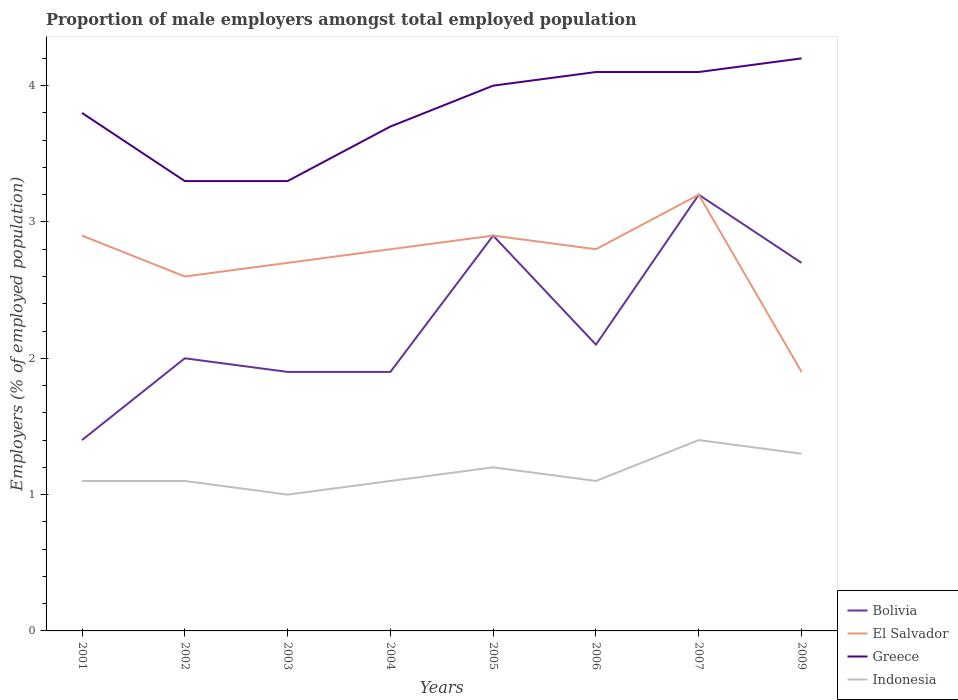How many different coloured lines are there?
Keep it short and to the point. 4. Across all years, what is the maximum proportion of male employers in Indonesia?
Ensure brevity in your answer.  1. In which year was the proportion of male employers in Bolivia maximum?
Give a very brief answer. 2001. What is the total proportion of male employers in Bolivia in the graph?
Give a very brief answer. 0.2. What is the difference between the highest and the second highest proportion of male employers in Bolivia?
Your response must be concise. 1.8. Are the values on the major ticks of Y-axis written in scientific E-notation?
Your response must be concise. No. Does the graph contain any zero values?
Provide a short and direct response. No. Does the graph contain grids?
Provide a short and direct response. No. How are the legend labels stacked?
Offer a terse response. Vertical. What is the title of the graph?
Provide a short and direct response. Proportion of male employers amongst total employed population. Does "Czech Republic" appear as one of the legend labels in the graph?
Your answer should be compact. No. What is the label or title of the X-axis?
Your answer should be very brief. Years. What is the label or title of the Y-axis?
Keep it short and to the point. Employers (% of employed population). What is the Employers (% of employed population) of Bolivia in 2001?
Offer a terse response. 1.4. What is the Employers (% of employed population) in El Salvador in 2001?
Keep it short and to the point. 2.9. What is the Employers (% of employed population) in Greece in 2001?
Your answer should be compact. 3.8. What is the Employers (% of employed population) of Indonesia in 2001?
Your response must be concise. 1.1. What is the Employers (% of employed population) in Bolivia in 2002?
Make the answer very short. 2. What is the Employers (% of employed population) of El Salvador in 2002?
Give a very brief answer. 2.6. What is the Employers (% of employed population) in Greece in 2002?
Keep it short and to the point. 3.3. What is the Employers (% of employed population) in Indonesia in 2002?
Give a very brief answer. 1.1. What is the Employers (% of employed population) in Bolivia in 2003?
Your answer should be compact. 1.9. What is the Employers (% of employed population) of El Salvador in 2003?
Offer a terse response. 2.7. What is the Employers (% of employed population) in Greece in 2003?
Your answer should be compact. 3.3. What is the Employers (% of employed population) in Bolivia in 2004?
Make the answer very short. 1.9. What is the Employers (% of employed population) in El Salvador in 2004?
Give a very brief answer. 2.8. What is the Employers (% of employed population) of Greece in 2004?
Offer a very short reply. 3.7. What is the Employers (% of employed population) in Indonesia in 2004?
Your answer should be very brief. 1.1. What is the Employers (% of employed population) in Bolivia in 2005?
Make the answer very short. 2.9. What is the Employers (% of employed population) of El Salvador in 2005?
Provide a succinct answer. 2.9. What is the Employers (% of employed population) in Greece in 2005?
Your response must be concise. 4. What is the Employers (% of employed population) of Indonesia in 2005?
Your answer should be compact. 1.2. What is the Employers (% of employed population) of Bolivia in 2006?
Offer a very short reply. 2.1. What is the Employers (% of employed population) in El Salvador in 2006?
Keep it short and to the point. 2.8. What is the Employers (% of employed population) in Greece in 2006?
Offer a terse response. 4.1. What is the Employers (% of employed population) of Indonesia in 2006?
Give a very brief answer. 1.1. What is the Employers (% of employed population) in Bolivia in 2007?
Your answer should be compact. 3.2. What is the Employers (% of employed population) of El Salvador in 2007?
Offer a terse response. 3.2. What is the Employers (% of employed population) of Greece in 2007?
Your answer should be very brief. 4.1. What is the Employers (% of employed population) in Indonesia in 2007?
Your answer should be compact. 1.4. What is the Employers (% of employed population) in Bolivia in 2009?
Your answer should be very brief. 2.7. What is the Employers (% of employed population) in El Salvador in 2009?
Your response must be concise. 1.9. What is the Employers (% of employed population) in Greece in 2009?
Provide a short and direct response. 4.2. What is the Employers (% of employed population) of Indonesia in 2009?
Provide a short and direct response. 1.3. Across all years, what is the maximum Employers (% of employed population) of Bolivia?
Give a very brief answer. 3.2. Across all years, what is the maximum Employers (% of employed population) in El Salvador?
Provide a succinct answer. 3.2. Across all years, what is the maximum Employers (% of employed population) in Greece?
Offer a very short reply. 4.2. Across all years, what is the maximum Employers (% of employed population) in Indonesia?
Your answer should be very brief. 1.4. Across all years, what is the minimum Employers (% of employed population) of Bolivia?
Your answer should be compact. 1.4. Across all years, what is the minimum Employers (% of employed population) of El Salvador?
Your answer should be compact. 1.9. Across all years, what is the minimum Employers (% of employed population) in Greece?
Ensure brevity in your answer.  3.3. What is the total Employers (% of employed population) in El Salvador in the graph?
Offer a very short reply. 21.8. What is the total Employers (% of employed population) of Greece in the graph?
Offer a terse response. 30.5. What is the difference between the Employers (% of employed population) in Greece in 2001 and that in 2002?
Offer a very short reply. 0.5. What is the difference between the Employers (% of employed population) in Indonesia in 2001 and that in 2002?
Offer a very short reply. 0. What is the difference between the Employers (% of employed population) of El Salvador in 2001 and that in 2003?
Your answer should be compact. 0.2. What is the difference between the Employers (% of employed population) of El Salvador in 2001 and that in 2006?
Your answer should be compact. 0.1. What is the difference between the Employers (% of employed population) in Greece in 2001 and that in 2006?
Your response must be concise. -0.3. What is the difference between the Employers (% of employed population) in Indonesia in 2001 and that in 2006?
Keep it short and to the point. 0. What is the difference between the Employers (% of employed population) of El Salvador in 2001 and that in 2007?
Provide a short and direct response. -0.3. What is the difference between the Employers (% of employed population) of Indonesia in 2001 and that in 2007?
Your response must be concise. -0.3. What is the difference between the Employers (% of employed population) of Greece in 2001 and that in 2009?
Your answer should be compact. -0.4. What is the difference between the Employers (% of employed population) in Indonesia in 2001 and that in 2009?
Give a very brief answer. -0.2. What is the difference between the Employers (% of employed population) in Bolivia in 2002 and that in 2003?
Keep it short and to the point. 0.1. What is the difference between the Employers (% of employed population) of El Salvador in 2002 and that in 2003?
Provide a succinct answer. -0.1. What is the difference between the Employers (% of employed population) in Greece in 2002 and that in 2003?
Your answer should be compact. 0. What is the difference between the Employers (% of employed population) in Indonesia in 2002 and that in 2003?
Your answer should be very brief. 0.1. What is the difference between the Employers (% of employed population) of El Salvador in 2002 and that in 2004?
Give a very brief answer. -0.2. What is the difference between the Employers (% of employed population) in Greece in 2002 and that in 2005?
Your response must be concise. -0.7. What is the difference between the Employers (% of employed population) of Bolivia in 2002 and that in 2006?
Your answer should be very brief. -0.1. What is the difference between the Employers (% of employed population) of Bolivia in 2002 and that in 2007?
Offer a very short reply. -1.2. What is the difference between the Employers (% of employed population) in El Salvador in 2002 and that in 2007?
Keep it short and to the point. -0.6. What is the difference between the Employers (% of employed population) in Greece in 2002 and that in 2007?
Your response must be concise. -0.8. What is the difference between the Employers (% of employed population) in Indonesia in 2002 and that in 2007?
Your response must be concise. -0.3. What is the difference between the Employers (% of employed population) in Bolivia in 2002 and that in 2009?
Offer a very short reply. -0.7. What is the difference between the Employers (% of employed population) of El Salvador in 2002 and that in 2009?
Your answer should be very brief. 0.7. What is the difference between the Employers (% of employed population) in Greece in 2002 and that in 2009?
Your response must be concise. -0.9. What is the difference between the Employers (% of employed population) in Greece in 2003 and that in 2004?
Provide a short and direct response. -0.4. What is the difference between the Employers (% of employed population) in Bolivia in 2003 and that in 2005?
Your response must be concise. -1. What is the difference between the Employers (% of employed population) in Greece in 2003 and that in 2005?
Give a very brief answer. -0.7. What is the difference between the Employers (% of employed population) in Indonesia in 2003 and that in 2005?
Provide a succinct answer. -0.2. What is the difference between the Employers (% of employed population) of Indonesia in 2003 and that in 2006?
Ensure brevity in your answer.  -0.1. What is the difference between the Employers (% of employed population) of El Salvador in 2003 and that in 2007?
Offer a terse response. -0.5. What is the difference between the Employers (% of employed population) in Greece in 2003 and that in 2007?
Offer a very short reply. -0.8. What is the difference between the Employers (% of employed population) of Bolivia in 2003 and that in 2009?
Provide a short and direct response. -0.8. What is the difference between the Employers (% of employed population) in El Salvador in 2004 and that in 2005?
Offer a very short reply. -0.1. What is the difference between the Employers (% of employed population) in Greece in 2004 and that in 2005?
Your response must be concise. -0.3. What is the difference between the Employers (% of employed population) of Greece in 2004 and that in 2006?
Provide a short and direct response. -0.4. What is the difference between the Employers (% of employed population) of Indonesia in 2004 and that in 2006?
Give a very brief answer. 0. What is the difference between the Employers (% of employed population) in El Salvador in 2004 and that in 2007?
Offer a terse response. -0.4. What is the difference between the Employers (% of employed population) in Indonesia in 2004 and that in 2009?
Your answer should be very brief. -0.2. What is the difference between the Employers (% of employed population) in Bolivia in 2005 and that in 2006?
Provide a succinct answer. 0.8. What is the difference between the Employers (% of employed population) of Bolivia in 2005 and that in 2007?
Your answer should be compact. -0.3. What is the difference between the Employers (% of employed population) of El Salvador in 2005 and that in 2007?
Make the answer very short. -0.3. What is the difference between the Employers (% of employed population) in Indonesia in 2005 and that in 2007?
Your response must be concise. -0.2. What is the difference between the Employers (% of employed population) of Greece in 2005 and that in 2009?
Provide a short and direct response. -0.2. What is the difference between the Employers (% of employed population) of Indonesia in 2005 and that in 2009?
Ensure brevity in your answer.  -0.1. What is the difference between the Employers (% of employed population) of Bolivia in 2006 and that in 2007?
Give a very brief answer. -1.1. What is the difference between the Employers (% of employed population) of Greece in 2006 and that in 2007?
Make the answer very short. 0. What is the difference between the Employers (% of employed population) in El Salvador in 2006 and that in 2009?
Make the answer very short. 0.9. What is the difference between the Employers (% of employed population) of Bolivia in 2007 and that in 2009?
Make the answer very short. 0.5. What is the difference between the Employers (% of employed population) in El Salvador in 2007 and that in 2009?
Your answer should be very brief. 1.3. What is the difference between the Employers (% of employed population) of Greece in 2007 and that in 2009?
Your answer should be very brief. -0.1. What is the difference between the Employers (% of employed population) of Indonesia in 2007 and that in 2009?
Provide a succinct answer. 0.1. What is the difference between the Employers (% of employed population) of Bolivia in 2001 and the Employers (% of employed population) of El Salvador in 2002?
Your response must be concise. -1.2. What is the difference between the Employers (% of employed population) of Bolivia in 2001 and the Employers (% of employed population) of Greece in 2002?
Ensure brevity in your answer.  -1.9. What is the difference between the Employers (% of employed population) in El Salvador in 2001 and the Employers (% of employed population) in Greece in 2002?
Your response must be concise. -0.4. What is the difference between the Employers (% of employed population) in Greece in 2001 and the Employers (% of employed population) in Indonesia in 2002?
Ensure brevity in your answer.  2.7. What is the difference between the Employers (% of employed population) in Bolivia in 2001 and the Employers (% of employed population) in El Salvador in 2003?
Make the answer very short. -1.3. What is the difference between the Employers (% of employed population) in Bolivia in 2001 and the Employers (% of employed population) in Greece in 2003?
Your response must be concise. -1.9. What is the difference between the Employers (% of employed population) of El Salvador in 2001 and the Employers (% of employed population) of Indonesia in 2003?
Keep it short and to the point. 1.9. What is the difference between the Employers (% of employed population) of Greece in 2001 and the Employers (% of employed population) of Indonesia in 2004?
Keep it short and to the point. 2.7. What is the difference between the Employers (% of employed population) in Bolivia in 2001 and the Employers (% of employed population) in Greece in 2005?
Ensure brevity in your answer.  -2.6. What is the difference between the Employers (% of employed population) of Bolivia in 2001 and the Employers (% of employed population) of Indonesia in 2005?
Make the answer very short. 0.2. What is the difference between the Employers (% of employed population) in Bolivia in 2001 and the Employers (% of employed population) in Greece in 2006?
Offer a very short reply. -2.7. What is the difference between the Employers (% of employed population) of Bolivia in 2001 and the Employers (% of employed population) of Indonesia in 2006?
Your answer should be compact. 0.3. What is the difference between the Employers (% of employed population) in Bolivia in 2001 and the Employers (% of employed population) in El Salvador in 2007?
Keep it short and to the point. -1.8. What is the difference between the Employers (% of employed population) of El Salvador in 2001 and the Employers (% of employed population) of Greece in 2007?
Your answer should be compact. -1.2. What is the difference between the Employers (% of employed population) in Bolivia in 2001 and the Employers (% of employed population) in El Salvador in 2009?
Your answer should be very brief. -0.5. What is the difference between the Employers (% of employed population) of Bolivia in 2001 and the Employers (% of employed population) of Indonesia in 2009?
Provide a short and direct response. 0.1. What is the difference between the Employers (% of employed population) of El Salvador in 2001 and the Employers (% of employed population) of Indonesia in 2009?
Your answer should be compact. 1.6. What is the difference between the Employers (% of employed population) in Bolivia in 2002 and the Employers (% of employed population) in Greece in 2003?
Make the answer very short. -1.3. What is the difference between the Employers (% of employed population) of Bolivia in 2002 and the Employers (% of employed population) of Indonesia in 2003?
Provide a succinct answer. 1. What is the difference between the Employers (% of employed population) of Bolivia in 2002 and the Employers (% of employed population) of El Salvador in 2004?
Provide a short and direct response. -0.8. What is the difference between the Employers (% of employed population) in Bolivia in 2002 and the Employers (% of employed population) in Greece in 2004?
Your answer should be very brief. -1.7. What is the difference between the Employers (% of employed population) in Greece in 2002 and the Employers (% of employed population) in Indonesia in 2004?
Your answer should be compact. 2.2. What is the difference between the Employers (% of employed population) of Bolivia in 2002 and the Employers (% of employed population) of El Salvador in 2005?
Provide a succinct answer. -0.9. What is the difference between the Employers (% of employed population) of Bolivia in 2002 and the Employers (% of employed population) of Indonesia in 2005?
Ensure brevity in your answer.  0.8. What is the difference between the Employers (% of employed population) of El Salvador in 2002 and the Employers (% of employed population) of Greece in 2005?
Your answer should be compact. -1.4. What is the difference between the Employers (% of employed population) of Bolivia in 2002 and the Employers (% of employed population) of El Salvador in 2006?
Your answer should be compact. -0.8. What is the difference between the Employers (% of employed population) of Bolivia in 2002 and the Employers (% of employed population) of Greece in 2006?
Provide a succinct answer. -2.1. What is the difference between the Employers (% of employed population) of El Salvador in 2002 and the Employers (% of employed population) of Greece in 2007?
Your response must be concise. -1.5. What is the difference between the Employers (% of employed population) in El Salvador in 2002 and the Employers (% of employed population) in Indonesia in 2007?
Offer a very short reply. 1.2. What is the difference between the Employers (% of employed population) in Greece in 2002 and the Employers (% of employed population) in Indonesia in 2007?
Offer a very short reply. 1.9. What is the difference between the Employers (% of employed population) in Bolivia in 2002 and the Employers (% of employed population) in Greece in 2009?
Your answer should be compact. -2.2. What is the difference between the Employers (% of employed population) of Bolivia in 2002 and the Employers (% of employed population) of Indonesia in 2009?
Offer a very short reply. 0.7. What is the difference between the Employers (% of employed population) in El Salvador in 2002 and the Employers (% of employed population) in Greece in 2009?
Your response must be concise. -1.6. What is the difference between the Employers (% of employed population) in El Salvador in 2002 and the Employers (% of employed population) in Indonesia in 2009?
Keep it short and to the point. 1.3. What is the difference between the Employers (% of employed population) of Greece in 2002 and the Employers (% of employed population) of Indonesia in 2009?
Your answer should be very brief. 2. What is the difference between the Employers (% of employed population) in Bolivia in 2003 and the Employers (% of employed population) in El Salvador in 2004?
Provide a succinct answer. -0.9. What is the difference between the Employers (% of employed population) in Bolivia in 2003 and the Employers (% of employed population) in Indonesia in 2004?
Provide a short and direct response. 0.8. What is the difference between the Employers (% of employed population) of El Salvador in 2003 and the Employers (% of employed population) of Indonesia in 2004?
Provide a short and direct response. 1.6. What is the difference between the Employers (% of employed population) of Bolivia in 2003 and the Employers (% of employed population) of El Salvador in 2005?
Ensure brevity in your answer.  -1. What is the difference between the Employers (% of employed population) of Bolivia in 2003 and the Employers (% of employed population) of Indonesia in 2005?
Your answer should be compact. 0.7. What is the difference between the Employers (% of employed population) in El Salvador in 2003 and the Employers (% of employed population) in Indonesia in 2005?
Keep it short and to the point. 1.5. What is the difference between the Employers (% of employed population) of Bolivia in 2003 and the Employers (% of employed population) of El Salvador in 2006?
Provide a succinct answer. -0.9. What is the difference between the Employers (% of employed population) in El Salvador in 2003 and the Employers (% of employed population) in Greece in 2006?
Offer a terse response. -1.4. What is the difference between the Employers (% of employed population) in El Salvador in 2003 and the Employers (% of employed population) in Indonesia in 2007?
Offer a terse response. 1.3. What is the difference between the Employers (% of employed population) of Greece in 2003 and the Employers (% of employed population) of Indonesia in 2007?
Offer a very short reply. 1.9. What is the difference between the Employers (% of employed population) of Bolivia in 2003 and the Employers (% of employed population) of El Salvador in 2009?
Make the answer very short. 0. What is the difference between the Employers (% of employed population) of Bolivia in 2003 and the Employers (% of employed population) of Indonesia in 2009?
Ensure brevity in your answer.  0.6. What is the difference between the Employers (% of employed population) of El Salvador in 2003 and the Employers (% of employed population) of Greece in 2009?
Your answer should be very brief. -1.5. What is the difference between the Employers (% of employed population) of Bolivia in 2004 and the Employers (% of employed population) of El Salvador in 2005?
Make the answer very short. -1. What is the difference between the Employers (% of employed population) of El Salvador in 2004 and the Employers (% of employed population) of Greece in 2005?
Ensure brevity in your answer.  -1.2. What is the difference between the Employers (% of employed population) in El Salvador in 2004 and the Employers (% of employed population) in Indonesia in 2005?
Your response must be concise. 1.6. What is the difference between the Employers (% of employed population) of Bolivia in 2004 and the Employers (% of employed population) of El Salvador in 2006?
Your answer should be very brief. -0.9. What is the difference between the Employers (% of employed population) in Bolivia in 2004 and the Employers (% of employed population) in El Salvador in 2007?
Offer a very short reply. -1.3. What is the difference between the Employers (% of employed population) of Bolivia in 2004 and the Employers (% of employed population) of Indonesia in 2007?
Keep it short and to the point. 0.5. What is the difference between the Employers (% of employed population) in El Salvador in 2004 and the Employers (% of employed population) in Greece in 2007?
Keep it short and to the point. -1.3. What is the difference between the Employers (% of employed population) of Bolivia in 2004 and the Employers (% of employed population) of El Salvador in 2009?
Your answer should be compact. 0. What is the difference between the Employers (% of employed population) of Bolivia in 2004 and the Employers (% of employed population) of Indonesia in 2009?
Make the answer very short. 0.6. What is the difference between the Employers (% of employed population) in Bolivia in 2005 and the Employers (% of employed population) in El Salvador in 2006?
Your answer should be very brief. 0.1. What is the difference between the Employers (% of employed population) of Bolivia in 2005 and the Employers (% of employed population) of Indonesia in 2006?
Your response must be concise. 1.8. What is the difference between the Employers (% of employed population) in El Salvador in 2005 and the Employers (% of employed population) in Greece in 2006?
Provide a short and direct response. -1.2. What is the difference between the Employers (% of employed population) of Bolivia in 2005 and the Employers (% of employed population) of Indonesia in 2007?
Your response must be concise. 1.5. What is the difference between the Employers (% of employed population) in El Salvador in 2005 and the Employers (% of employed population) in Indonesia in 2007?
Keep it short and to the point. 1.5. What is the difference between the Employers (% of employed population) of Greece in 2005 and the Employers (% of employed population) of Indonesia in 2007?
Your answer should be very brief. 2.6. What is the difference between the Employers (% of employed population) of Bolivia in 2005 and the Employers (% of employed population) of El Salvador in 2009?
Give a very brief answer. 1. What is the difference between the Employers (% of employed population) in Bolivia in 2005 and the Employers (% of employed population) in Greece in 2009?
Offer a very short reply. -1.3. What is the difference between the Employers (% of employed population) in Bolivia in 2005 and the Employers (% of employed population) in Indonesia in 2009?
Give a very brief answer. 1.6. What is the difference between the Employers (% of employed population) in El Salvador in 2005 and the Employers (% of employed population) in Indonesia in 2009?
Your answer should be compact. 1.6. What is the difference between the Employers (% of employed population) in Bolivia in 2006 and the Employers (% of employed population) in El Salvador in 2007?
Your response must be concise. -1.1. What is the difference between the Employers (% of employed population) of El Salvador in 2006 and the Employers (% of employed population) of Greece in 2007?
Provide a short and direct response. -1.3. What is the difference between the Employers (% of employed population) in El Salvador in 2006 and the Employers (% of employed population) in Indonesia in 2007?
Offer a terse response. 1.4. What is the difference between the Employers (% of employed population) of Bolivia in 2006 and the Employers (% of employed population) of El Salvador in 2009?
Give a very brief answer. 0.2. What is the difference between the Employers (% of employed population) in Bolivia in 2006 and the Employers (% of employed population) in Indonesia in 2009?
Give a very brief answer. 0.8. What is the difference between the Employers (% of employed population) in El Salvador in 2006 and the Employers (% of employed population) in Greece in 2009?
Make the answer very short. -1.4. What is the difference between the Employers (% of employed population) of Bolivia in 2007 and the Employers (% of employed population) of El Salvador in 2009?
Keep it short and to the point. 1.3. What is the difference between the Employers (% of employed population) in Bolivia in 2007 and the Employers (% of employed population) in Greece in 2009?
Give a very brief answer. -1. What is the difference between the Employers (% of employed population) in Bolivia in 2007 and the Employers (% of employed population) in Indonesia in 2009?
Offer a very short reply. 1.9. What is the difference between the Employers (% of employed population) of El Salvador in 2007 and the Employers (% of employed population) of Indonesia in 2009?
Provide a short and direct response. 1.9. What is the average Employers (% of employed population) of Bolivia per year?
Your answer should be compact. 2.26. What is the average Employers (% of employed population) in El Salvador per year?
Provide a succinct answer. 2.73. What is the average Employers (% of employed population) of Greece per year?
Your answer should be compact. 3.81. What is the average Employers (% of employed population) in Indonesia per year?
Your answer should be compact. 1.16. In the year 2001, what is the difference between the Employers (% of employed population) of Bolivia and Employers (% of employed population) of El Salvador?
Keep it short and to the point. -1.5. In the year 2001, what is the difference between the Employers (% of employed population) in El Salvador and Employers (% of employed population) in Indonesia?
Your response must be concise. 1.8. In the year 2001, what is the difference between the Employers (% of employed population) of Greece and Employers (% of employed population) of Indonesia?
Keep it short and to the point. 2.7. In the year 2002, what is the difference between the Employers (% of employed population) in Bolivia and Employers (% of employed population) in Greece?
Provide a succinct answer. -1.3. In the year 2002, what is the difference between the Employers (% of employed population) of El Salvador and Employers (% of employed population) of Greece?
Ensure brevity in your answer.  -0.7. In the year 2002, what is the difference between the Employers (% of employed population) in El Salvador and Employers (% of employed population) in Indonesia?
Your answer should be very brief. 1.5. In the year 2003, what is the difference between the Employers (% of employed population) of Bolivia and Employers (% of employed population) of Indonesia?
Make the answer very short. 0.9. In the year 2003, what is the difference between the Employers (% of employed population) of Greece and Employers (% of employed population) of Indonesia?
Your answer should be compact. 2.3. In the year 2004, what is the difference between the Employers (% of employed population) of Bolivia and Employers (% of employed population) of Indonesia?
Keep it short and to the point. 0.8. In the year 2004, what is the difference between the Employers (% of employed population) in El Salvador and Employers (% of employed population) in Indonesia?
Give a very brief answer. 1.7. In the year 2004, what is the difference between the Employers (% of employed population) of Greece and Employers (% of employed population) of Indonesia?
Give a very brief answer. 2.6. In the year 2005, what is the difference between the Employers (% of employed population) of El Salvador and Employers (% of employed population) of Greece?
Provide a succinct answer. -1.1. In the year 2006, what is the difference between the Employers (% of employed population) of Bolivia and Employers (% of employed population) of El Salvador?
Your response must be concise. -0.7. In the year 2006, what is the difference between the Employers (% of employed population) in Bolivia and Employers (% of employed population) in Greece?
Offer a very short reply. -2. In the year 2006, what is the difference between the Employers (% of employed population) of Bolivia and Employers (% of employed population) of Indonesia?
Your answer should be very brief. 1. In the year 2006, what is the difference between the Employers (% of employed population) in Greece and Employers (% of employed population) in Indonesia?
Your answer should be compact. 3. In the year 2007, what is the difference between the Employers (% of employed population) in Bolivia and Employers (% of employed population) in El Salvador?
Provide a short and direct response. 0. In the year 2007, what is the difference between the Employers (% of employed population) in Bolivia and Employers (% of employed population) in Greece?
Offer a very short reply. -0.9. In the year 2007, what is the difference between the Employers (% of employed population) of El Salvador and Employers (% of employed population) of Greece?
Your answer should be compact. -0.9. In the year 2007, what is the difference between the Employers (% of employed population) of Greece and Employers (% of employed population) of Indonesia?
Your response must be concise. 2.7. In the year 2009, what is the difference between the Employers (% of employed population) in Bolivia and Employers (% of employed population) in El Salvador?
Your answer should be very brief. 0.8. In the year 2009, what is the difference between the Employers (% of employed population) in Bolivia and Employers (% of employed population) in Greece?
Provide a succinct answer. -1.5. In the year 2009, what is the difference between the Employers (% of employed population) of Bolivia and Employers (% of employed population) of Indonesia?
Ensure brevity in your answer.  1.4. In the year 2009, what is the difference between the Employers (% of employed population) of Greece and Employers (% of employed population) of Indonesia?
Your answer should be compact. 2.9. What is the ratio of the Employers (% of employed population) in Bolivia in 2001 to that in 2002?
Provide a succinct answer. 0.7. What is the ratio of the Employers (% of employed population) in El Salvador in 2001 to that in 2002?
Give a very brief answer. 1.12. What is the ratio of the Employers (% of employed population) in Greece in 2001 to that in 2002?
Your answer should be compact. 1.15. What is the ratio of the Employers (% of employed population) in Bolivia in 2001 to that in 2003?
Offer a very short reply. 0.74. What is the ratio of the Employers (% of employed population) in El Salvador in 2001 to that in 2003?
Provide a short and direct response. 1.07. What is the ratio of the Employers (% of employed population) in Greece in 2001 to that in 2003?
Ensure brevity in your answer.  1.15. What is the ratio of the Employers (% of employed population) of Bolivia in 2001 to that in 2004?
Offer a terse response. 0.74. What is the ratio of the Employers (% of employed population) of El Salvador in 2001 to that in 2004?
Give a very brief answer. 1.04. What is the ratio of the Employers (% of employed population) in Greece in 2001 to that in 2004?
Ensure brevity in your answer.  1.03. What is the ratio of the Employers (% of employed population) of Bolivia in 2001 to that in 2005?
Your answer should be compact. 0.48. What is the ratio of the Employers (% of employed population) in El Salvador in 2001 to that in 2005?
Make the answer very short. 1. What is the ratio of the Employers (% of employed population) of Indonesia in 2001 to that in 2005?
Your answer should be very brief. 0.92. What is the ratio of the Employers (% of employed population) in Bolivia in 2001 to that in 2006?
Offer a terse response. 0.67. What is the ratio of the Employers (% of employed population) of El Salvador in 2001 to that in 2006?
Make the answer very short. 1.04. What is the ratio of the Employers (% of employed population) of Greece in 2001 to that in 2006?
Offer a very short reply. 0.93. What is the ratio of the Employers (% of employed population) of Indonesia in 2001 to that in 2006?
Your answer should be compact. 1. What is the ratio of the Employers (% of employed population) in Bolivia in 2001 to that in 2007?
Your answer should be very brief. 0.44. What is the ratio of the Employers (% of employed population) of El Salvador in 2001 to that in 2007?
Offer a very short reply. 0.91. What is the ratio of the Employers (% of employed population) in Greece in 2001 to that in 2007?
Your answer should be very brief. 0.93. What is the ratio of the Employers (% of employed population) in Indonesia in 2001 to that in 2007?
Provide a succinct answer. 0.79. What is the ratio of the Employers (% of employed population) in Bolivia in 2001 to that in 2009?
Offer a very short reply. 0.52. What is the ratio of the Employers (% of employed population) of El Salvador in 2001 to that in 2009?
Keep it short and to the point. 1.53. What is the ratio of the Employers (% of employed population) of Greece in 2001 to that in 2009?
Give a very brief answer. 0.9. What is the ratio of the Employers (% of employed population) in Indonesia in 2001 to that in 2009?
Your response must be concise. 0.85. What is the ratio of the Employers (% of employed population) in Bolivia in 2002 to that in 2003?
Keep it short and to the point. 1.05. What is the ratio of the Employers (% of employed population) of Greece in 2002 to that in 2003?
Keep it short and to the point. 1. What is the ratio of the Employers (% of employed population) in Bolivia in 2002 to that in 2004?
Provide a short and direct response. 1.05. What is the ratio of the Employers (% of employed population) of Greece in 2002 to that in 2004?
Your answer should be very brief. 0.89. What is the ratio of the Employers (% of employed population) in Bolivia in 2002 to that in 2005?
Your answer should be compact. 0.69. What is the ratio of the Employers (% of employed population) in El Salvador in 2002 to that in 2005?
Offer a very short reply. 0.9. What is the ratio of the Employers (% of employed population) of Greece in 2002 to that in 2005?
Provide a short and direct response. 0.82. What is the ratio of the Employers (% of employed population) in Indonesia in 2002 to that in 2005?
Offer a very short reply. 0.92. What is the ratio of the Employers (% of employed population) of Greece in 2002 to that in 2006?
Keep it short and to the point. 0.8. What is the ratio of the Employers (% of employed population) in Bolivia in 2002 to that in 2007?
Offer a terse response. 0.62. What is the ratio of the Employers (% of employed population) of El Salvador in 2002 to that in 2007?
Keep it short and to the point. 0.81. What is the ratio of the Employers (% of employed population) in Greece in 2002 to that in 2007?
Make the answer very short. 0.8. What is the ratio of the Employers (% of employed population) of Indonesia in 2002 to that in 2007?
Ensure brevity in your answer.  0.79. What is the ratio of the Employers (% of employed population) in Bolivia in 2002 to that in 2009?
Keep it short and to the point. 0.74. What is the ratio of the Employers (% of employed population) in El Salvador in 2002 to that in 2009?
Your answer should be very brief. 1.37. What is the ratio of the Employers (% of employed population) of Greece in 2002 to that in 2009?
Offer a terse response. 0.79. What is the ratio of the Employers (% of employed population) of Indonesia in 2002 to that in 2009?
Give a very brief answer. 0.85. What is the ratio of the Employers (% of employed population) in Bolivia in 2003 to that in 2004?
Ensure brevity in your answer.  1. What is the ratio of the Employers (% of employed population) of Greece in 2003 to that in 2004?
Keep it short and to the point. 0.89. What is the ratio of the Employers (% of employed population) of Bolivia in 2003 to that in 2005?
Give a very brief answer. 0.66. What is the ratio of the Employers (% of employed population) of Greece in 2003 to that in 2005?
Offer a terse response. 0.82. What is the ratio of the Employers (% of employed population) of Bolivia in 2003 to that in 2006?
Provide a succinct answer. 0.9. What is the ratio of the Employers (% of employed population) of El Salvador in 2003 to that in 2006?
Make the answer very short. 0.96. What is the ratio of the Employers (% of employed population) of Greece in 2003 to that in 2006?
Ensure brevity in your answer.  0.8. What is the ratio of the Employers (% of employed population) in Bolivia in 2003 to that in 2007?
Offer a terse response. 0.59. What is the ratio of the Employers (% of employed population) of El Salvador in 2003 to that in 2007?
Keep it short and to the point. 0.84. What is the ratio of the Employers (% of employed population) in Greece in 2003 to that in 2007?
Ensure brevity in your answer.  0.8. What is the ratio of the Employers (% of employed population) in Indonesia in 2003 to that in 2007?
Give a very brief answer. 0.71. What is the ratio of the Employers (% of employed population) in Bolivia in 2003 to that in 2009?
Your answer should be compact. 0.7. What is the ratio of the Employers (% of employed population) in El Salvador in 2003 to that in 2009?
Make the answer very short. 1.42. What is the ratio of the Employers (% of employed population) of Greece in 2003 to that in 2009?
Keep it short and to the point. 0.79. What is the ratio of the Employers (% of employed population) in Indonesia in 2003 to that in 2009?
Give a very brief answer. 0.77. What is the ratio of the Employers (% of employed population) of Bolivia in 2004 to that in 2005?
Ensure brevity in your answer.  0.66. What is the ratio of the Employers (% of employed population) of El Salvador in 2004 to that in 2005?
Your answer should be very brief. 0.97. What is the ratio of the Employers (% of employed population) of Greece in 2004 to that in 2005?
Your answer should be compact. 0.93. What is the ratio of the Employers (% of employed population) of Bolivia in 2004 to that in 2006?
Ensure brevity in your answer.  0.9. What is the ratio of the Employers (% of employed population) in Greece in 2004 to that in 2006?
Your answer should be very brief. 0.9. What is the ratio of the Employers (% of employed population) in Bolivia in 2004 to that in 2007?
Provide a succinct answer. 0.59. What is the ratio of the Employers (% of employed population) in El Salvador in 2004 to that in 2007?
Provide a short and direct response. 0.88. What is the ratio of the Employers (% of employed population) of Greece in 2004 to that in 2007?
Ensure brevity in your answer.  0.9. What is the ratio of the Employers (% of employed population) in Indonesia in 2004 to that in 2007?
Provide a succinct answer. 0.79. What is the ratio of the Employers (% of employed population) in Bolivia in 2004 to that in 2009?
Offer a terse response. 0.7. What is the ratio of the Employers (% of employed population) in El Salvador in 2004 to that in 2009?
Ensure brevity in your answer.  1.47. What is the ratio of the Employers (% of employed population) in Greece in 2004 to that in 2009?
Give a very brief answer. 0.88. What is the ratio of the Employers (% of employed population) of Indonesia in 2004 to that in 2009?
Make the answer very short. 0.85. What is the ratio of the Employers (% of employed population) of Bolivia in 2005 to that in 2006?
Give a very brief answer. 1.38. What is the ratio of the Employers (% of employed population) of El Salvador in 2005 to that in 2006?
Keep it short and to the point. 1.04. What is the ratio of the Employers (% of employed population) of Greece in 2005 to that in 2006?
Provide a short and direct response. 0.98. What is the ratio of the Employers (% of employed population) of Bolivia in 2005 to that in 2007?
Ensure brevity in your answer.  0.91. What is the ratio of the Employers (% of employed population) in El Salvador in 2005 to that in 2007?
Make the answer very short. 0.91. What is the ratio of the Employers (% of employed population) in Greece in 2005 to that in 2007?
Provide a succinct answer. 0.98. What is the ratio of the Employers (% of employed population) in Indonesia in 2005 to that in 2007?
Keep it short and to the point. 0.86. What is the ratio of the Employers (% of employed population) in Bolivia in 2005 to that in 2009?
Provide a short and direct response. 1.07. What is the ratio of the Employers (% of employed population) in El Salvador in 2005 to that in 2009?
Provide a short and direct response. 1.53. What is the ratio of the Employers (% of employed population) in Bolivia in 2006 to that in 2007?
Your answer should be compact. 0.66. What is the ratio of the Employers (% of employed population) of Greece in 2006 to that in 2007?
Your answer should be compact. 1. What is the ratio of the Employers (% of employed population) in Indonesia in 2006 to that in 2007?
Your answer should be compact. 0.79. What is the ratio of the Employers (% of employed population) in Bolivia in 2006 to that in 2009?
Your response must be concise. 0.78. What is the ratio of the Employers (% of employed population) in El Salvador in 2006 to that in 2009?
Keep it short and to the point. 1.47. What is the ratio of the Employers (% of employed population) of Greece in 2006 to that in 2009?
Provide a short and direct response. 0.98. What is the ratio of the Employers (% of employed population) in Indonesia in 2006 to that in 2009?
Make the answer very short. 0.85. What is the ratio of the Employers (% of employed population) in Bolivia in 2007 to that in 2009?
Provide a succinct answer. 1.19. What is the ratio of the Employers (% of employed population) in El Salvador in 2007 to that in 2009?
Your answer should be very brief. 1.68. What is the ratio of the Employers (% of employed population) in Greece in 2007 to that in 2009?
Keep it short and to the point. 0.98. What is the difference between the highest and the second highest Employers (% of employed population) of El Salvador?
Your answer should be compact. 0.3. What is the difference between the highest and the second highest Employers (% of employed population) in Greece?
Offer a terse response. 0.1. What is the difference between the highest and the second highest Employers (% of employed population) in Indonesia?
Provide a succinct answer. 0.1. What is the difference between the highest and the lowest Employers (% of employed population) of Bolivia?
Your answer should be compact. 1.8. What is the difference between the highest and the lowest Employers (% of employed population) of Greece?
Your answer should be compact. 0.9. 